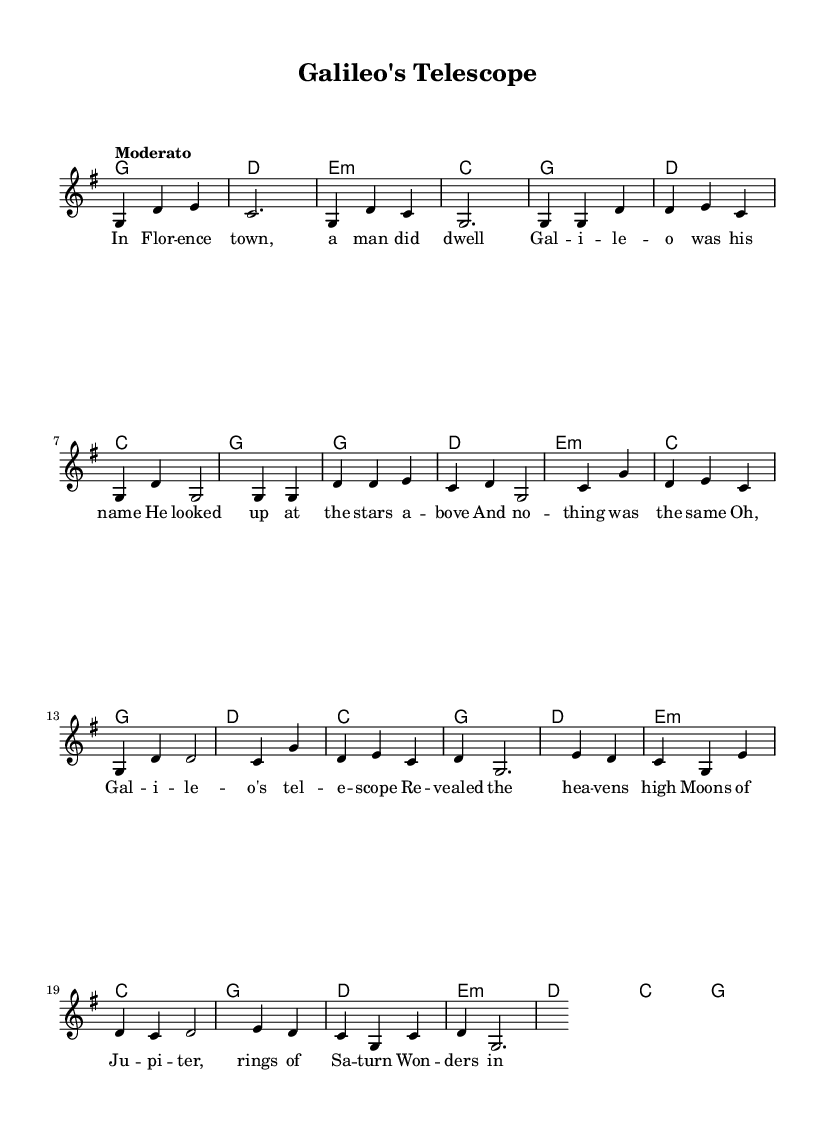What is the key signature of this music? The key signature indicates that the music is in G major. G major has one sharp (F#), which is indicated on the staff.
Answer: G major What is the time signature of this music? The time signature is defined at the beginning of the piece, showing a pattern of three quarter-note beats in each measure, which is indicated as 3/4.
Answer: 3/4 What is the tempo marking of this score? The tempo marking, which suggests the speed of the music, is indicated as "Moderato", meaning moderately fast.
Answer: Moderato How many measures are there in the chorus? By carefully counting the distinct musical sections labeled as a chorus, there are a total of four measures present in the chorus as indicated by the notation.
Answer: 4 Which scientific fact is referenced in the lyrics? The lyrics allude to Galileo's telescope discovering celestial objects, mentioning "Moons of Jupiter" and "rings of Saturn." This indicates the scientific discoveries he made.
Answer: Moons of Jupiter, rings of Saturn What is the structure of the song from the beginning? The song follows a structure starting with an introduction, followed by verses, a chorus, and a bridge. This structure outlines how the sections are organized across the entire piece.
Answer: Intro, Verse 1, Chorus, Bridge Are there any repeated sections in the song? The song features several repeated sections, particularly in the verses and chorus. This repetition can be seen where phrases are musically reiterated, contributing to its folk style.
Answer: Yes, verses and chorus are repeated 